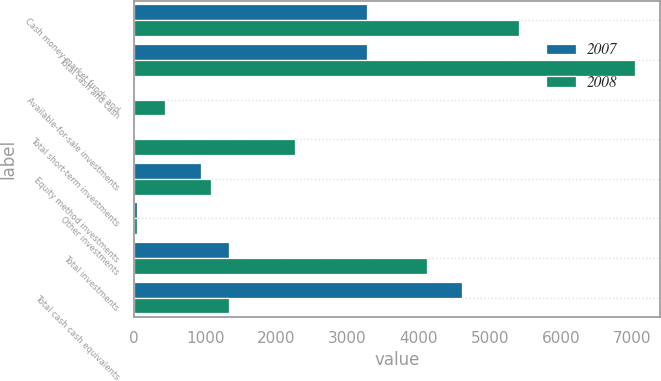Convert chart to OTSL. <chart><loc_0><loc_0><loc_500><loc_500><stacked_bar_chart><ecel><fcel>Cash money market funds and<fcel>Total cash and cash<fcel>Available-for-sale investments<fcel>Total short-term investments<fcel>Equity method investments<fcel>Other investments<fcel>Total investments<fcel>Total cash cash equivalents<nl><fcel>2007<fcel>3268<fcel>3268<fcel>11<fcel>11<fcel>942<fcel>45<fcel>1328<fcel>4607<nl><fcel>2008<fcel>5406<fcel>7042<fcel>442<fcel>2266<fcel>1085<fcel>44<fcel>4111<fcel>1328<nl></chart> 